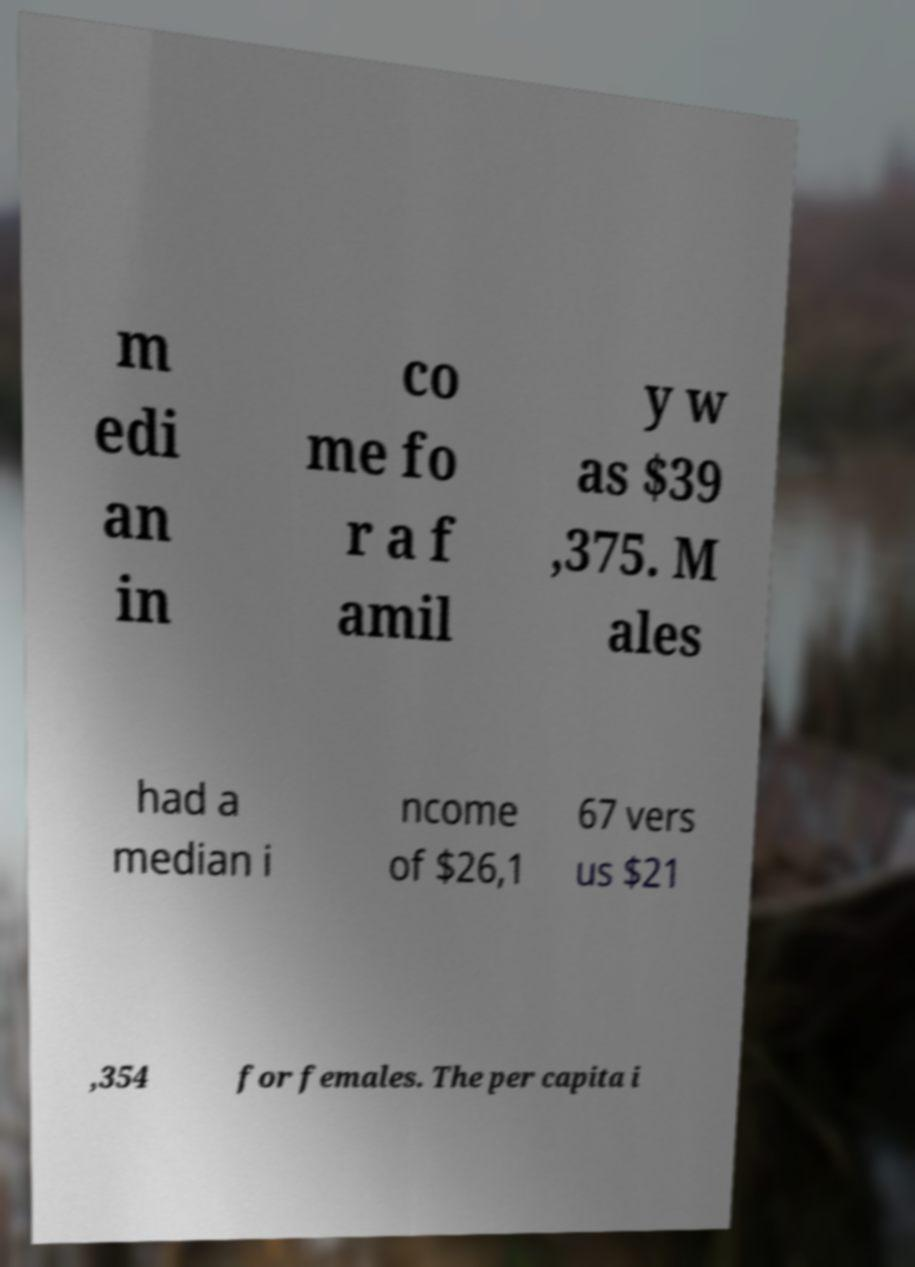I need the written content from this picture converted into text. Can you do that? m edi an in co me fo r a f amil y w as $39 ,375. M ales had a median i ncome of $26,1 67 vers us $21 ,354 for females. The per capita i 